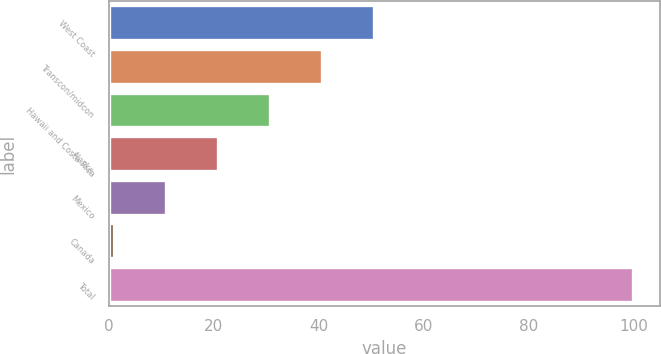Convert chart. <chart><loc_0><loc_0><loc_500><loc_500><bar_chart><fcel>West Coast<fcel>Transcon/midcon<fcel>Hawaii and Costa Rica<fcel>Alaska<fcel>Mexico<fcel>Canada<fcel>Total<nl><fcel>50.5<fcel>40.6<fcel>30.7<fcel>20.8<fcel>10.9<fcel>1<fcel>100<nl></chart> 